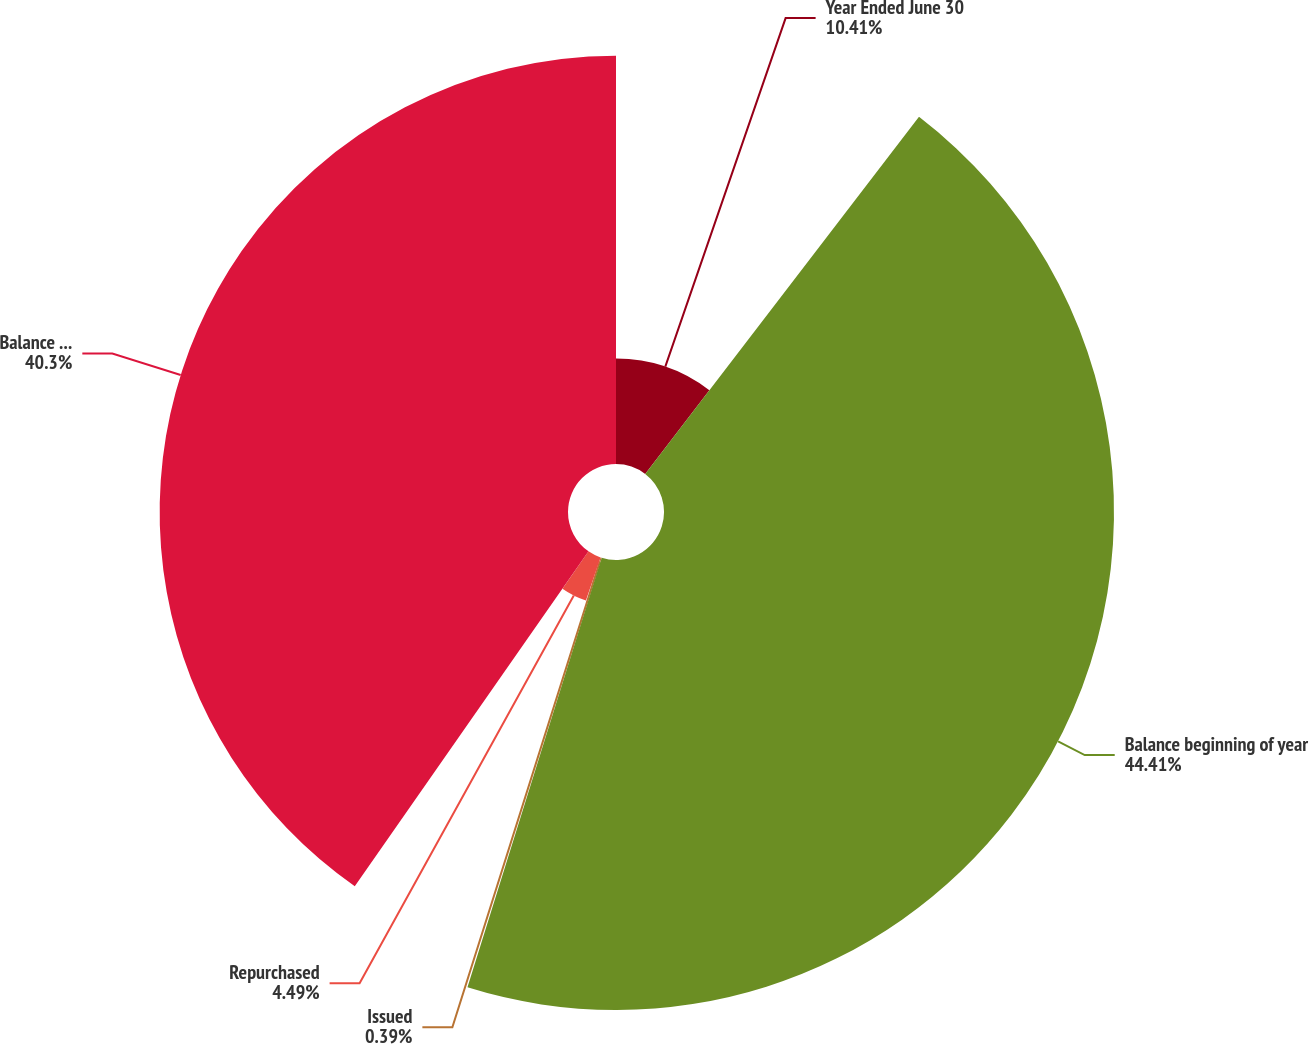Convert chart. <chart><loc_0><loc_0><loc_500><loc_500><pie_chart><fcel>Year Ended June 30<fcel>Balance beginning of year<fcel>Issued<fcel>Repurchased<fcel>Balance end of year<nl><fcel>10.41%<fcel>44.41%<fcel>0.39%<fcel>4.49%<fcel>40.3%<nl></chart> 